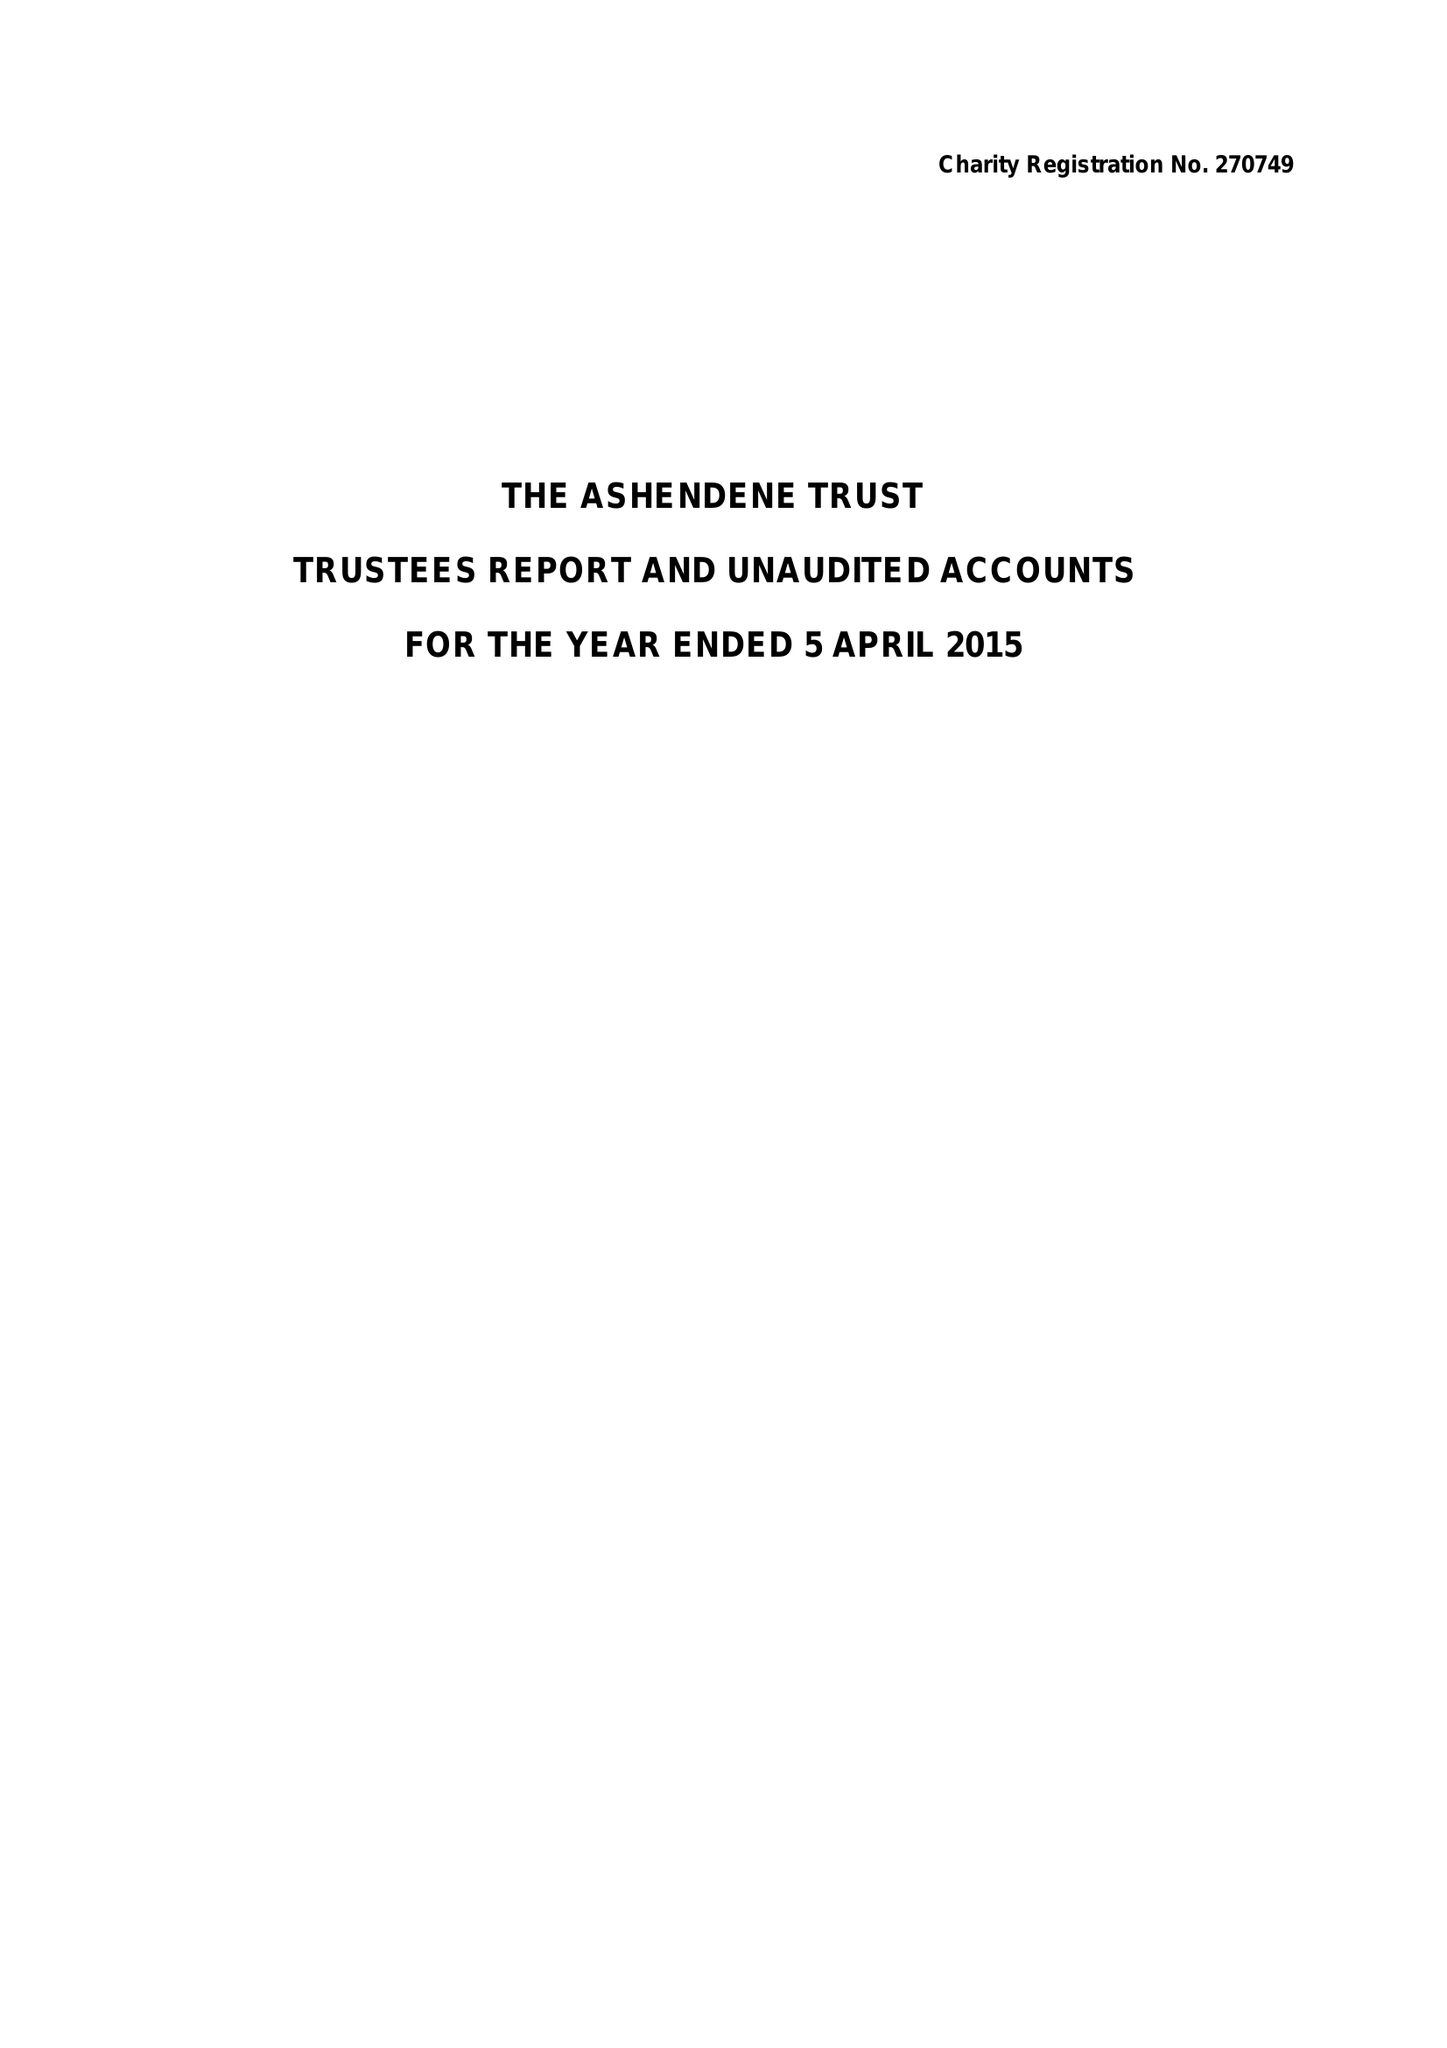What is the value for the address__street_line?
Answer the question using a single word or phrase. 34 SACKVILLE STREET 